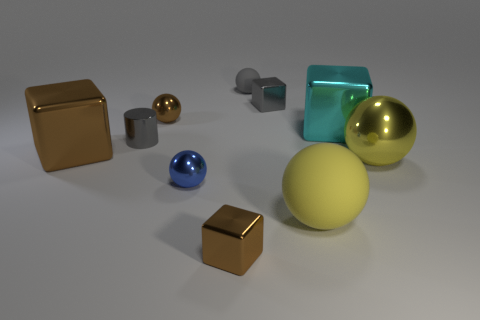Do the metal ball to the right of the large cyan object and the large matte ball have the same color?
Offer a very short reply. Yes. How many gray cylinders are in front of the cyan thing?
Offer a terse response. 1. Is the material of the large brown object the same as the gray sphere?
Your answer should be compact. No. What number of tiny metallic things are in front of the cyan metallic thing and behind the large yellow shiny sphere?
Keep it short and to the point. 1. How many other things are there of the same color as the cylinder?
Offer a terse response. 2. How many brown objects are big metal balls or shiny spheres?
Provide a short and direct response. 1. How big is the cyan cube?
Keep it short and to the point. Large. How many shiny objects are big yellow balls or large cyan cubes?
Make the answer very short. 2. Is the number of small gray metal cylinders less than the number of large purple rubber cylinders?
Provide a short and direct response. No. What number of other objects are the same material as the tiny brown ball?
Your response must be concise. 7. 